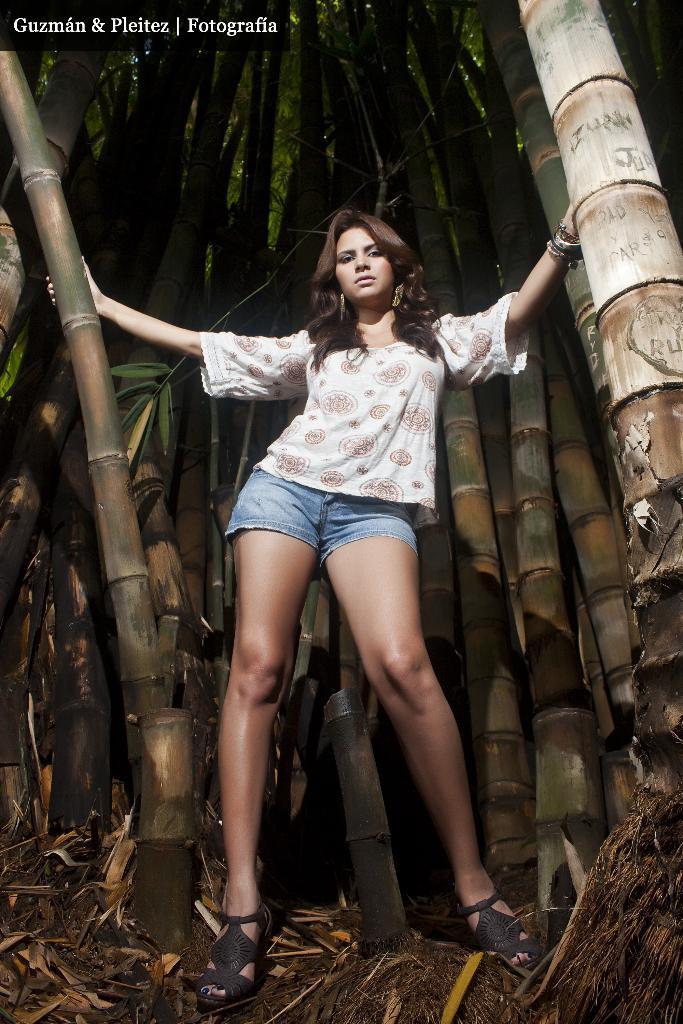Describe this image in one or two sentences. In this image we can see a lady person wearing white color T-shirt, blue color top standing near the bamboo trees and in the background of the image there are some bamboo trees. 